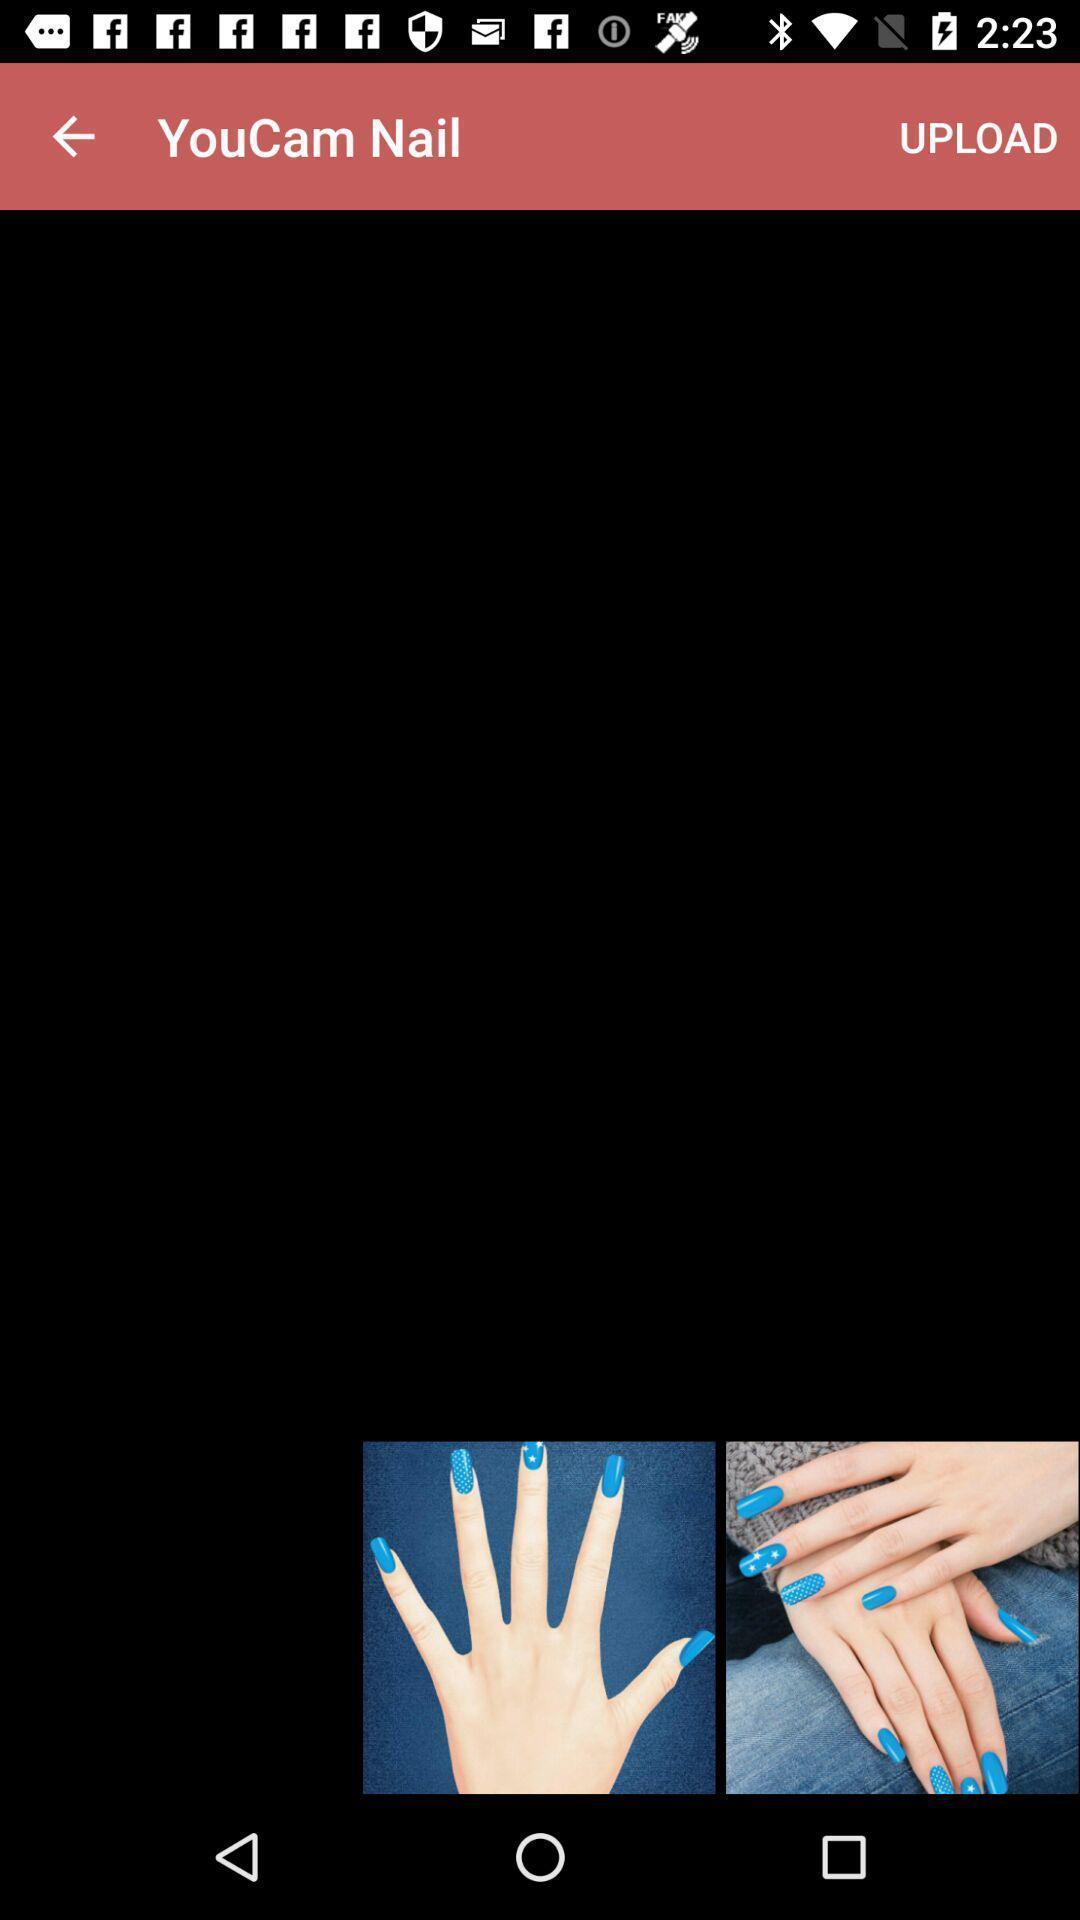Explain what's happening in this screen capture. Page that displaying photo editing application. 